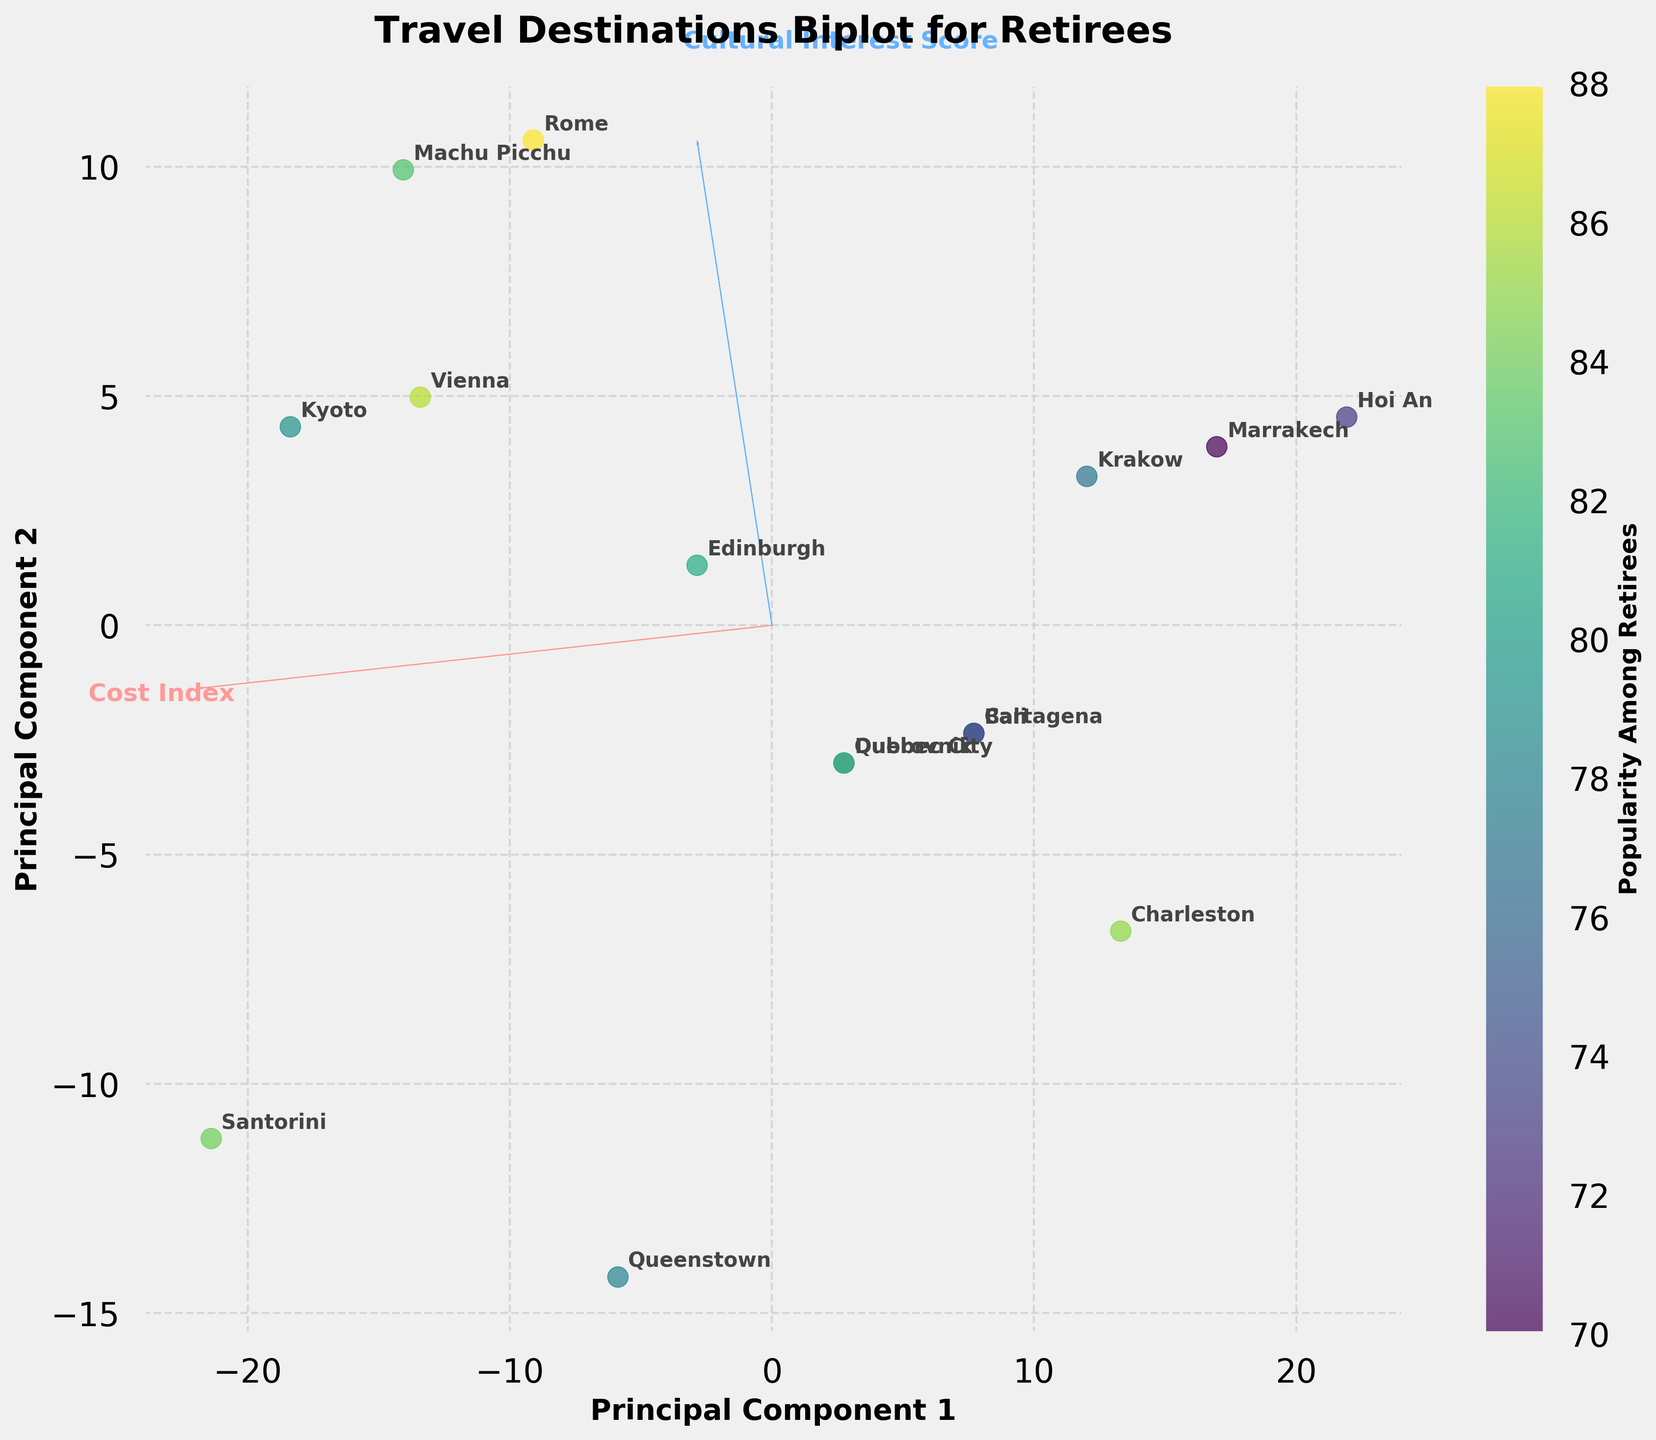How many destinations are visualized in the biplot? Count the number of labeled points on the plot. Each point represents a travel destination.
Answer: 15 What are the axes labeled as in the biplot? The axes are labeled on the plot. Look for the text along the x-axis and y-axis.
Answer: Principal Component 1 and Principal Component 2 Which destination has the highest popularity among retirees based on color intensity? Identify the destination with the darkest color. Darker colors represent higher popularity.
Answer: Rome Is there a visible trend between cost index and cultural interest score based on the biplot's PC vectors? Observe the direction of the arrows for 'Cost Index' and 'Cultural Interest Score'. If they align closely, there is a strong correlation; if perpendicular, weak or no correlation.
Answer: Weak or No correlation Which destination has a higher cost index: Kyoto or Santorini? Identify the positions of Kyoto and Santorini. The direction closer to the 'Cost Index' vector indicates a higher cost index.
Answer: Santorini What does the direction of the PC1 axis represent in terms of the features? Look at the relationship between the PC1 axis and the feature vectors. Higher PC1 values align with stronger projection of these features.
Answer: Cultural Interest Score What does the position of Queenstown indicate about its cultural interest score? Determine the position of Queenstown relative to the 'Cultural Interest Score' vector. The closer it is, the higher the score.
Answer: Relatively Low Which two destinations are closest to each other, indicating similar profiles in the biplot? Look for the two labeled points that are nearest to each other on the scatter.
Answer: Cartagena and Bali How does Vienna compare to Marrakech in terms of both cost index and cultural interest score? Compare their positions relative to 'Cost Index' and 'Cultural Interest Score' vectors. Vienna is closer to both feature vectors compared to Marrakech.
Answer: Higher in both Do the destinations with high cultural interest also tend to be more popular among retirees? Observe if destinations near the 'Cultural Interest Score' arrow (high values) have darker colors indicating popularity.
Answer: Yes 